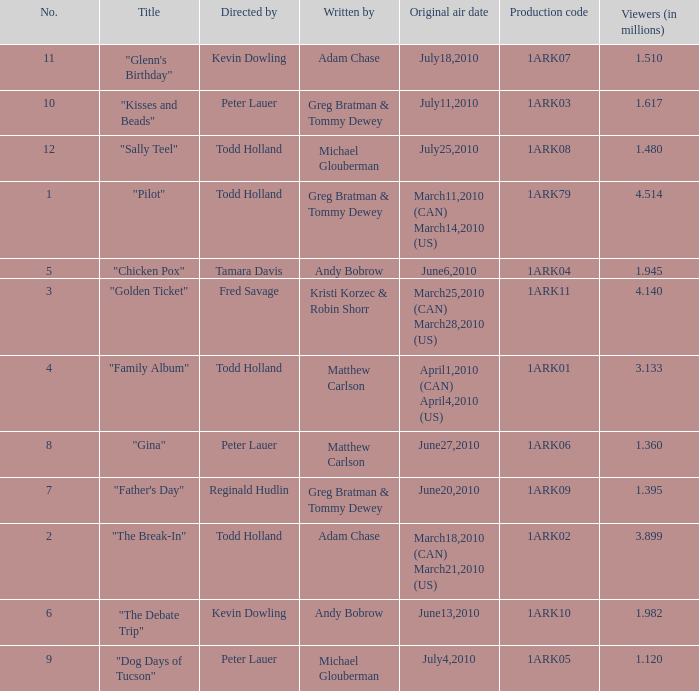What is the original air date for production code 1ark79? March11,2010 (CAN) March14,2010 (US). 